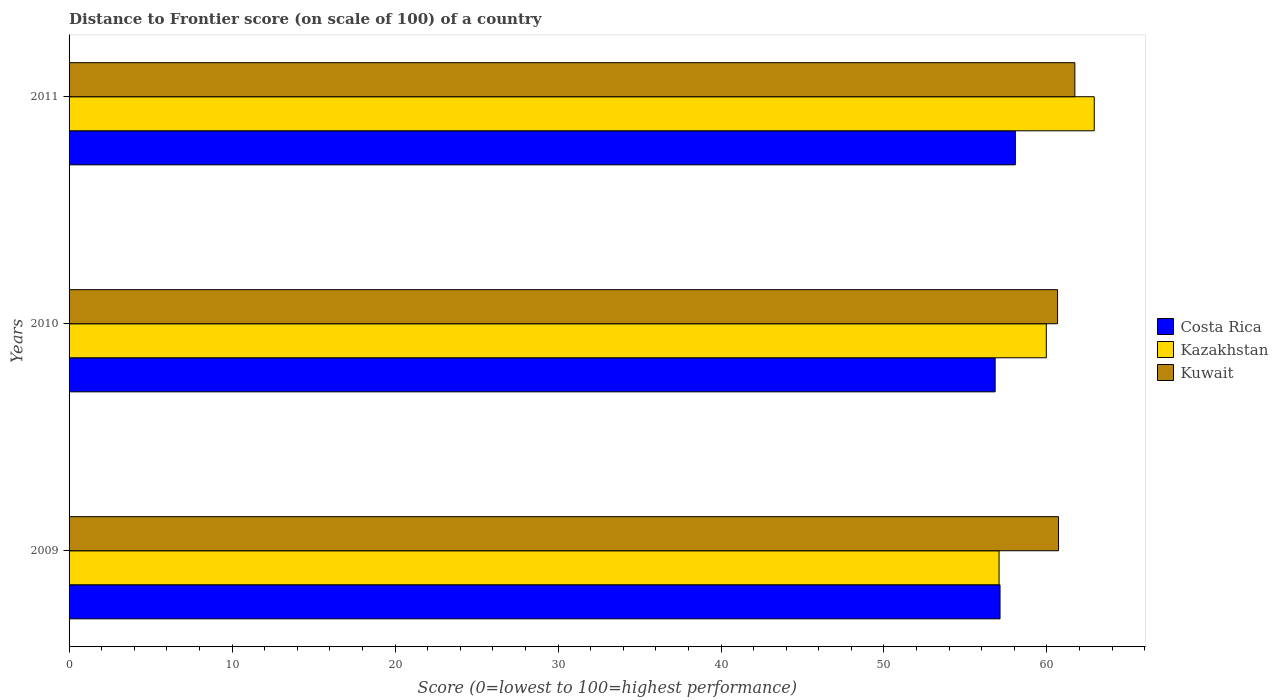How many groups of bars are there?
Make the answer very short. 3. Are the number of bars per tick equal to the number of legend labels?
Make the answer very short. Yes. How many bars are there on the 1st tick from the top?
Offer a very short reply. 3. What is the label of the 3rd group of bars from the top?
Ensure brevity in your answer.  2009. What is the distance to frontier score of in Kuwait in 2011?
Your answer should be very brief. 61.71. Across all years, what is the maximum distance to frontier score of in Kuwait?
Your answer should be very brief. 61.71. Across all years, what is the minimum distance to frontier score of in Kazakhstan?
Ensure brevity in your answer.  57.06. What is the total distance to frontier score of in Kazakhstan in the graph?
Offer a terse response. 179.92. What is the difference between the distance to frontier score of in Kazakhstan in 2009 and that in 2010?
Your response must be concise. -2.9. What is the difference between the distance to frontier score of in Kuwait in 2010 and the distance to frontier score of in Costa Rica in 2011?
Give a very brief answer. 2.59. What is the average distance to frontier score of in Costa Rica per year?
Provide a short and direct response. 57.33. In the year 2011, what is the difference between the distance to frontier score of in Kuwait and distance to frontier score of in Costa Rica?
Your answer should be compact. 3.65. In how many years, is the distance to frontier score of in Kazakhstan greater than 12 ?
Ensure brevity in your answer.  3. What is the ratio of the distance to frontier score of in Kazakhstan in 2009 to that in 2010?
Your answer should be very brief. 0.95. Is the distance to frontier score of in Kuwait in 2009 less than that in 2010?
Ensure brevity in your answer.  No. What is the difference between the highest and the lowest distance to frontier score of in Kuwait?
Your answer should be very brief. 1.06. In how many years, is the distance to frontier score of in Costa Rica greater than the average distance to frontier score of in Costa Rica taken over all years?
Your answer should be very brief. 1. What does the 2nd bar from the top in 2009 represents?
Keep it short and to the point. Kazakhstan. What does the 3rd bar from the bottom in 2010 represents?
Ensure brevity in your answer.  Kuwait. Is it the case that in every year, the sum of the distance to frontier score of in Kuwait and distance to frontier score of in Costa Rica is greater than the distance to frontier score of in Kazakhstan?
Provide a succinct answer. Yes. What is the difference between two consecutive major ticks on the X-axis?
Ensure brevity in your answer.  10. Are the values on the major ticks of X-axis written in scientific E-notation?
Offer a very short reply. No. Does the graph contain any zero values?
Offer a terse response. No. Does the graph contain grids?
Your answer should be compact. No. Where does the legend appear in the graph?
Offer a terse response. Center right. How many legend labels are there?
Keep it short and to the point. 3. How are the legend labels stacked?
Provide a succinct answer. Vertical. What is the title of the graph?
Ensure brevity in your answer.  Distance to Frontier score (on scale of 100) of a country. What is the label or title of the X-axis?
Keep it short and to the point. Score (0=lowest to 100=highest performance). What is the Score (0=lowest to 100=highest performance) of Costa Rica in 2009?
Ensure brevity in your answer.  57.12. What is the Score (0=lowest to 100=highest performance) in Kazakhstan in 2009?
Offer a terse response. 57.06. What is the Score (0=lowest to 100=highest performance) in Kuwait in 2009?
Ensure brevity in your answer.  60.71. What is the Score (0=lowest to 100=highest performance) of Costa Rica in 2010?
Make the answer very short. 56.82. What is the Score (0=lowest to 100=highest performance) in Kazakhstan in 2010?
Provide a succinct answer. 59.96. What is the Score (0=lowest to 100=highest performance) in Kuwait in 2010?
Provide a short and direct response. 60.65. What is the Score (0=lowest to 100=highest performance) of Costa Rica in 2011?
Your answer should be compact. 58.06. What is the Score (0=lowest to 100=highest performance) in Kazakhstan in 2011?
Your response must be concise. 62.9. What is the Score (0=lowest to 100=highest performance) of Kuwait in 2011?
Provide a succinct answer. 61.71. Across all years, what is the maximum Score (0=lowest to 100=highest performance) in Costa Rica?
Provide a short and direct response. 58.06. Across all years, what is the maximum Score (0=lowest to 100=highest performance) in Kazakhstan?
Offer a terse response. 62.9. Across all years, what is the maximum Score (0=lowest to 100=highest performance) of Kuwait?
Offer a terse response. 61.71. Across all years, what is the minimum Score (0=lowest to 100=highest performance) in Costa Rica?
Offer a terse response. 56.82. Across all years, what is the minimum Score (0=lowest to 100=highest performance) in Kazakhstan?
Keep it short and to the point. 57.06. Across all years, what is the minimum Score (0=lowest to 100=highest performance) of Kuwait?
Give a very brief answer. 60.65. What is the total Score (0=lowest to 100=highest performance) in Costa Rica in the graph?
Make the answer very short. 172. What is the total Score (0=lowest to 100=highest performance) of Kazakhstan in the graph?
Offer a very short reply. 179.92. What is the total Score (0=lowest to 100=highest performance) in Kuwait in the graph?
Keep it short and to the point. 183.07. What is the difference between the Score (0=lowest to 100=highest performance) in Kuwait in 2009 and that in 2010?
Offer a very short reply. 0.06. What is the difference between the Score (0=lowest to 100=highest performance) in Costa Rica in 2009 and that in 2011?
Keep it short and to the point. -0.94. What is the difference between the Score (0=lowest to 100=highest performance) of Kazakhstan in 2009 and that in 2011?
Make the answer very short. -5.84. What is the difference between the Score (0=lowest to 100=highest performance) of Kuwait in 2009 and that in 2011?
Offer a very short reply. -1. What is the difference between the Score (0=lowest to 100=highest performance) in Costa Rica in 2010 and that in 2011?
Provide a succinct answer. -1.24. What is the difference between the Score (0=lowest to 100=highest performance) of Kazakhstan in 2010 and that in 2011?
Offer a very short reply. -2.94. What is the difference between the Score (0=lowest to 100=highest performance) in Kuwait in 2010 and that in 2011?
Ensure brevity in your answer.  -1.06. What is the difference between the Score (0=lowest to 100=highest performance) in Costa Rica in 2009 and the Score (0=lowest to 100=highest performance) in Kazakhstan in 2010?
Make the answer very short. -2.84. What is the difference between the Score (0=lowest to 100=highest performance) of Costa Rica in 2009 and the Score (0=lowest to 100=highest performance) of Kuwait in 2010?
Provide a succinct answer. -3.53. What is the difference between the Score (0=lowest to 100=highest performance) in Kazakhstan in 2009 and the Score (0=lowest to 100=highest performance) in Kuwait in 2010?
Offer a terse response. -3.59. What is the difference between the Score (0=lowest to 100=highest performance) in Costa Rica in 2009 and the Score (0=lowest to 100=highest performance) in Kazakhstan in 2011?
Provide a succinct answer. -5.78. What is the difference between the Score (0=lowest to 100=highest performance) of Costa Rica in 2009 and the Score (0=lowest to 100=highest performance) of Kuwait in 2011?
Give a very brief answer. -4.59. What is the difference between the Score (0=lowest to 100=highest performance) in Kazakhstan in 2009 and the Score (0=lowest to 100=highest performance) in Kuwait in 2011?
Provide a succinct answer. -4.65. What is the difference between the Score (0=lowest to 100=highest performance) of Costa Rica in 2010 and the Score (0=lowest to 100=highest performance) of Kazakhstan in 2011?
Provide a succinct answer. -6.08. What is the difference between the Score (0=lowest to 100=highest performance) in Costa Rica in 2010 and the Score (0=lowest to 100=highest performance) in Kuwait in 2011?
Provide a short and direct response. -4.89. What is the difference between the Score (0=lowest to 100=highest performance) of Kazakhstan in 2010 and the Score (0=lowest to 100=highest performance) of Kuwait in 2011?
Ensure brevity in your answer.  -1.75. What is the average Score (0=lowest to 100=highest performance) of Costa Rica per year?
Your answer should be very brief. 57.33. What is the average Score (0=lowest to 100=highest performance) of Kazakhstan per year?
Provide a short and direct response. 59.97. What is the average Score (0=lowest to 100=highest performance) in Kuwait per year?
Your answer should be compact. 61.02. In the year 2009, what is the difference between the Score (0=lowest to 100=highest performance) of Costa Rica and Score (0=lowest to 100=highest performance) of Kuwait?
Make the answer very short. -3.59. In the year 2009, what is the difference between the Score (0=lowest to 100=highest performance) in Kazakhstan and Score (0=lowest to 100=highest performance) in Kuwait?
Offer a terse response. -3.65. In the year 2010, what is the difference between the Score (0=lowest to 100=highest performance) in Costa Rica and Score (0=lowest to 100=highest performance) in Kazakhstan?
Give a very brief answer. -3.14. In the year 2010, what is the difference between the Score (0=lowest to 100=highest performance) of Costa Rica and Score (0=lowest to 100=highest performance) of Kuwait?
Make the answer very short. -3.83. In the year 2010, what is the difference between the Score (0=lowest to 100=highest performance) of Kazakhstan and Score (0=lowest to 100=highest performance) of Kuwait?
Your answer should be compact. -0.69. In the year 2011, what is the difference between the Score (0=lowest to 100=highest performance) of Costa Rica and Score (0=lowest to 100=highest performance) of Kazakhstan?
Your answer should be very brief. -4.84. In the year 2011, what is the difference between the Score (0=lowest to 100=highest performance) in Costa Rica and Score (0=lowest to 100=highest performance) in Kuwait?
Provide a succinct answer. -3.65. In the year 2011, what is the difference between the Score (0=lowest to 100=highest performance) of Kazakhstan and Score (0=lowest to 100=highest performance) of Kuwait?
Make the answer very short. 1.19. What is the ratio of the Score (0=lowest to 100=highest performance) in Costa Rica in 2009 to that in 2010?
Provide a short and direct response. 1.01. What is the ratio of the Score (0=lowest to 100=highest performance) of Kazakhstan in 2009 to that in 2010?
Give a very brief answer. 0.95. What is the ratio of the Score (0=lowest to 100=highest performance) in Kuwait in 2009 to that in 2010?
Keep it short and to the point. 1. What is the ratio of the Score (0=lowest to 100=highest performance) in Costa Rica in 2009 to that in 2011?
Offer a terse response. 0.98. What is the ratio of the Score (0=lowest to 100=highest performance) of Kazakhstan in 2009 to that in 2011?
Give a very brief answer. 0.91. What is the ratio of the Score (0=lowest to 100=highest performance) of Kuwait in 2009 to that in 2011?
Your answer should be very brief. 0.98. What is the ratio of the Score (0=lowest to 100=highest performance) of Costa Rica in 2010 to that in 2011?
Your answer should be compact. 0.98. What is the ratio of the Score (0=lowest to 100=highest performance) in Kazakhstan in 2010 to that in 2011?
Give a very brief answer. 0.95. What is the ratio of the Score (0=lowest to 100=highest performance) of Kuwait in 2010 to that in 2011?
Offer a terse response. 0.98. What is the difference between the highest and the second highest Score (0=lowest to 100=highest performance) in Costa Rica?
Your answer should be compact. 0.94. What is the difference between the highest and the second highest Score (0=lowest to 100=highest performance) in Kazakhstan?
Your response must be concise. 2.94. What is the difference between the highest and the second highest Score (0=lowest to 100=highest performance) in Kuwait?
Ensure brevity in your answer.  1. What is the difference between the highest and the lowest Score (0=lowest to 100=highest performance) of Costa Rica?
Keep it short and to the point. 1.24. What is the difference between the highest and the lowest Score (0=lowest to 100=highest performance) in Kazakhstan?
Make the answer very short. 5.84. What is the difference between the highest and the lowest Score (0=lowest to 100=highest performance) of Kuwait?
Ensure brevity in your answer.  1.06. 